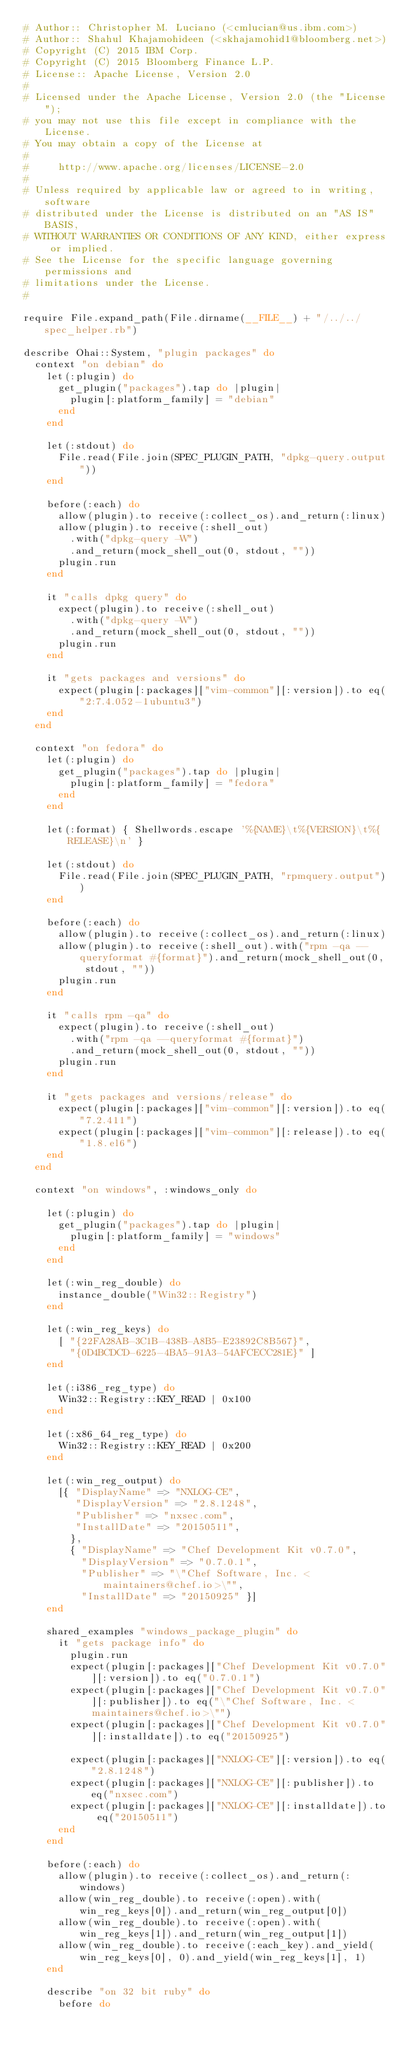<code> <loc_0><loc_0><loc_500><loc_500><_Ruby_># Author:: Christopher M. Luciano (<cmlucian@us.ibm.com>)
# Author:: Shahul Khajamohideen (<skhajamohid1@bloomberg.net>)
# Copyright (C) 2015 IBM Corp.
# Copyright (C) 2015 Bloomberg Finance L.P.
# License:: Apache License, Version 2.0
#
# Licensed under the Apache License, Version 2.0 (the "License");
# you may not use this file except in compliance with the License.
# You may obtain a copy of the License at
#
#     http://www.apache.org/licenses/LICENSE-2.0
#
# Unless required by applicable law or agreed to in writing, software
# distributed under the License is distributed on an "AS IS" BASIS,
# WITHOUT WARRANTIES OR CONDITIONS OF ANY KIND, either express or implied.
# See the License for the specific language governing permissions and
# limitations under the License.
#

require File.expand_path(File.dirname(__FILE__) + "/../../spec_helper.rb")

describe Ohai::System, "plugin packages" do
  context "on debian" do
    let(:plugin) do
      get_plugin("packages").tap do |plugin|
        plugin[:platform_family] = "debian"
      end
    end

    let(:stdout) do
      File.read(File.join(SPEC_PLUGIN_PATH, "dpkg-query.output"))
    end

    before(:each) do
      allow(plugin).to receive(:collect_os).and_return(:linux)
      allow(plugin).to receive(:shell_out)
        .with("dpkg-query -W")
        .and_return(mock_shell_out(0, stdout, ""))
      plugin.run
    end

    it "calls dpkg query" do
      expect(plugin).to receive(:shell_out)
        .with("dpkg-query -W")
        .and_return(mock_shell_out(0, stdout, ""))
      plugin.run
    end

    it "gets packages and versions" do
      expect(plugin[:packages]["vim-common"][:version]).to eq("2:7.4.052-1ubuntu3")
    end
  end

  context "on fedora" do
    let(:plugin) do
      get_plugin("packages").tap do |plugin|
        plugin[:platform_family] = "fedora"
      end
    end

    let(:format) { Shellwords.escape '%{NAME}\t%{VERSION}\t%{RELEASE}\n' }

    let(:stdout) do
      File.read(File.join(SPEC_PLUGIN_PATH, "rpmquery.output"))
    end

    before(:each) do
      allow(plugin).to receive(:collect_os).and_return(:linux)
      allow(plugin).to receive(:shell_out).with("rpm -qa --queryformat #{format}").and_return(mock_shell_out(0, stdout, ""))
      plugin.run
    end

    it "calls rpm -qa" do
      expect(plugin).to receive(:shell_out)
        .with("rpm -qa --queryformat #{format}")
        .and_return(mock_shell_out(0, stdout, ""))
      plugin.run
    end

    it "gets packages and versions/release" do
      expect(plugin[:packages]["vim-common"][:version]).to eq("7.2.411")
      expect(plugin[:packages]["vim-common"][:release]).to eq("1.8.el6")
    end
  end

  context "on windows", :windows_only do

    let(:plugin) do
      get_plugin("packages").tap do |plugin|
        plugin[:platform_family] = "windows"
      end
    end

    let(:win_reg_double) do
      instance_double("Win32::Registry")
    end

    let(:win_reg_keys) do
      [ "{22FA28AB-3C1B-438B-A8B5-E23892C8B567}",
        "{0D4BCDCD-6225-4BA5-91A3-54AFCECC281E}" ]
    end

    let(:i386_reg_type) do
      Win32::Registry::KEY_READ | 0x100
    end

    let(:x86_64_reg_type) do
      Win32::Registry::KEY_READ | 0x200
    end

    let(:win_reg_output) do
      [{ "DisplayName" => "NXLOG-CE",
         "DisplayVersion" => "2.8.1248",
         "Publisher" => "nxsec.com",
         "InstallDate" => "20150511",
        },
        { "DisplayName" => "Chef Development Kit v0.7.0",
          "DisplayVersion" => "0.7.0.1",
          "Publisher" => "\"Chef Software, Inc. <maintainers@chef.io>\"",
          "InstallDate" => "20150925" }]
    end

    shared_examples "windows_package_plugin" do
      it "gets package info" do
        plugin.run
        expect(plugin[:packages]["Chef Development Kit v0.7.0"][:version]).to eq("0.7.0.1")
        expect(plugin[:packages]["Chef Development Kit v0.7.0"][:publisher]).to eq("\"Chef Software, Inc. <maintainers@chef.io>\"")
        expect(plugin[:packages]["Chef Development Kit v0.7.0"][:installdate]).to eq("20150925")

        expect(plugin[:packages]["NXLOG-CE"][:version]).to eq("2.8.1248")
        expect(plugin[:packages]["NXLOG-CE"][:publisher]).to eq("nxsec.com")
        expect(plugin[:packages]["NXLOG-CE"][:installdate]).to eq("20150511")
      end
    end

    before(:each) do
      allow(plugin).to receive(:collect_os).and_return(:windows)
      allow(win_reg_double).to receive(:open).with(win_reg_keys[0]).and_return(win_reg_output[0])
      allow(win_reg_double).to receive(:open).with(win_reg_keys[1]).and_return(win_reg_output[1])
      allow(win_reg_double).to receive(:each_key).and_yield(win_reg_keys[0], 0).and_yield(win_reg_keys[1], 1)
    end

    describe "on 32 bit ruby" do
      before do</code> 